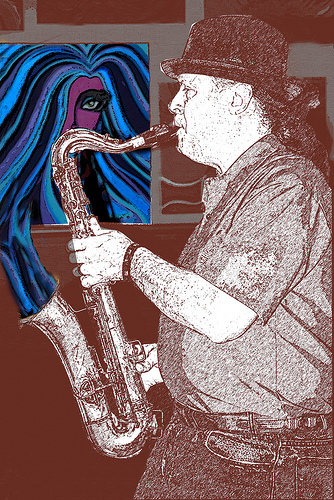<image>
Can you confirm if the sax is under the painting? Yes. The sax is positioned underneath the painting, with the painting above it in the vertical space. 